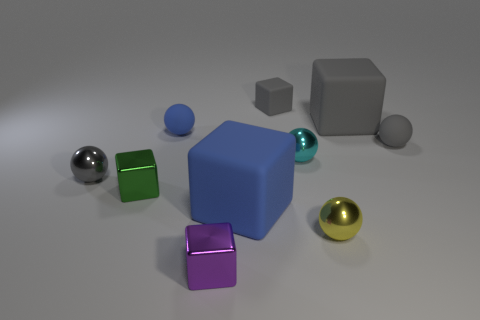There is a tiny ball that is behind the gray ball that is right of the tiny purple thing; what color is it?
Your answer should be compact. Blue. How many green objects are on the right side of the big blue matte cube?
Your answer should be very brief. 0. What is the color of the tiny matte cube?
Give a very brief answer. Gray. How many large objects are either gray objects or shiny spheres?
Offer a very short reply. 1. There is a shiny block left of the purple cube; does it have the same color as the tiny shiny ball that is in front of the big blue cube?
Provide a short and direct response. No. How many other objects are there of the same color as the small matte cube?
Make the answer very short. 3. What is the shape of the gray thing to the left of the small gray rubber cube?
Your response must be concise. Sphere. Are there fewer blue balls than big cyan rubber blocks?
Your answer should be very brief. No. Do the small block that is in front of the green metallic object and the large blue block have the same material?
Give a very brief answer. No. Is there any other thing that has the same size as the blue rubber cube?
Give a very brief answer. Yes. 